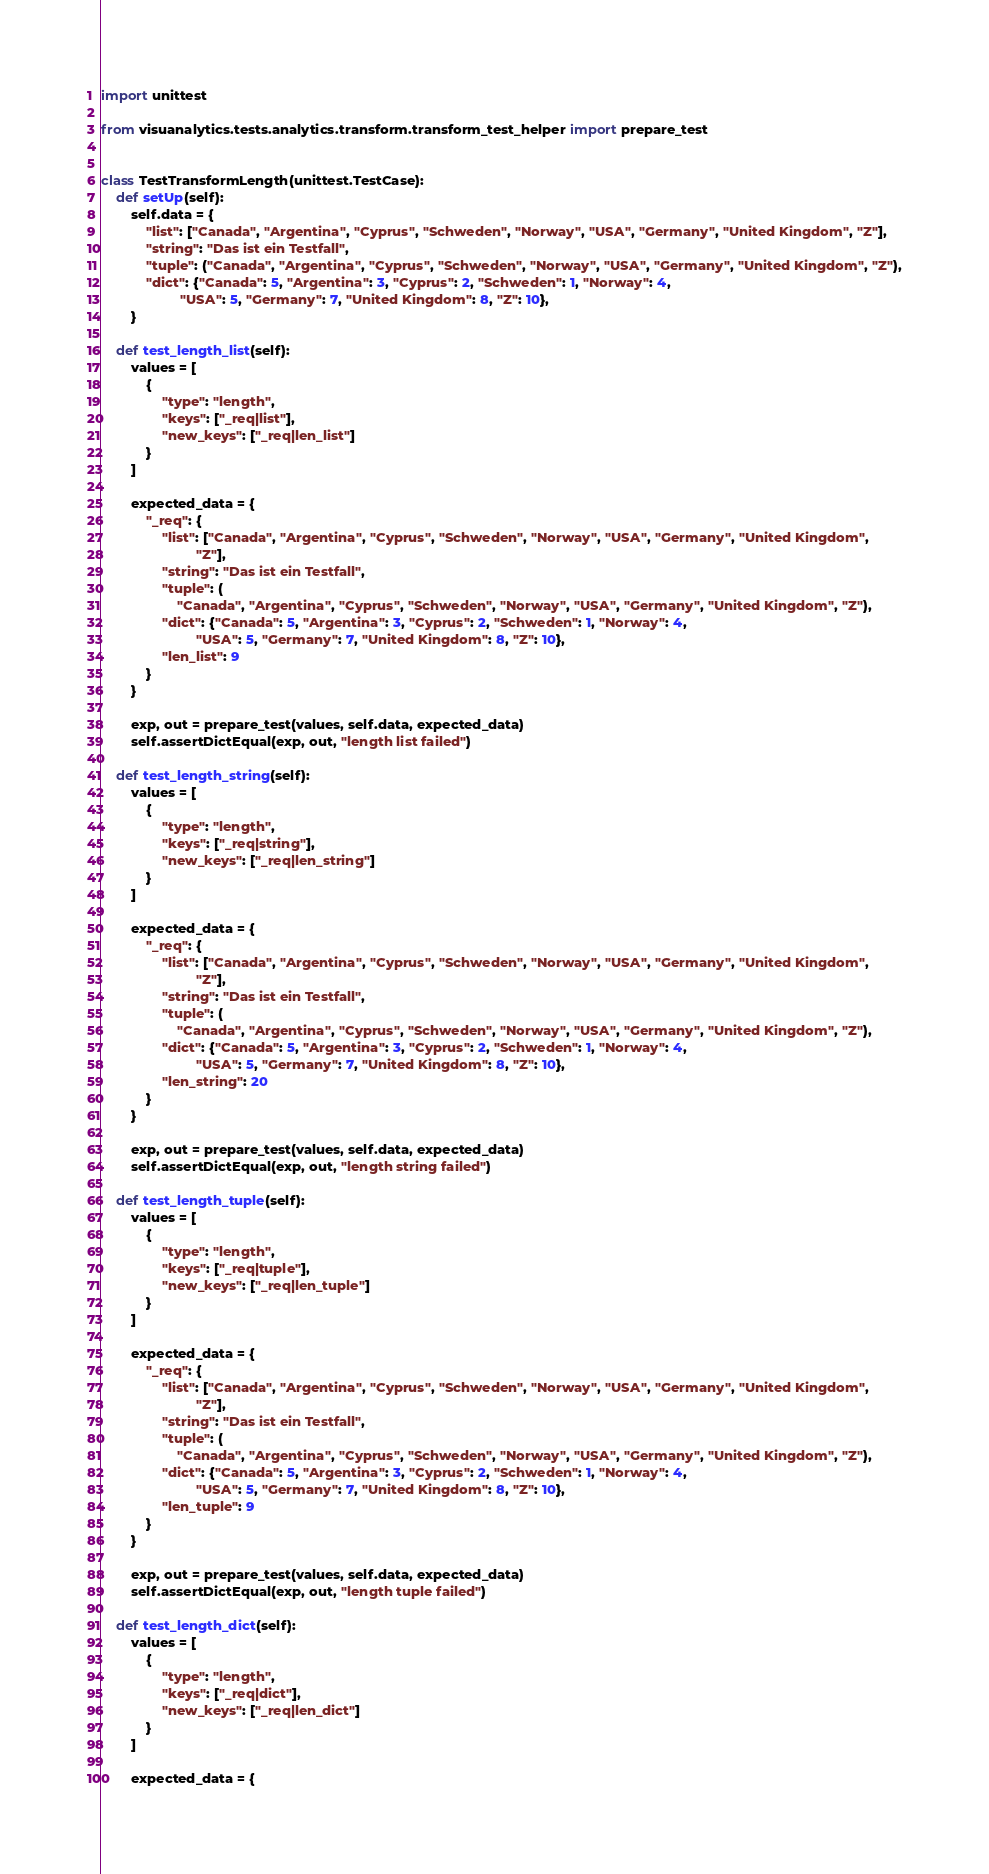Convert code to text. <code><loc_0><loc_0><loc_500><loc_500><_Python_>import unittest

from visuanalytics.tests.analytics.transform.transform_test_helper import prepare_test


class TestTransformLength(unittest.TestCase):
    def setUp(self):
        self.data = {
            "list": ["Canada", "Argentina", "Cyprus", "Schweden", "Norway", "USA", "Germany", "United Kingdom", "Z"],
            "string": "Das ist ein Testfall",
            "tuple": ("Canada", "Argentina", "Cyprus", "Schweden", "Norway", "USA", "Germany", "United Kingdom", "Z"),
            "dict": {"Canada": 5, "Argentina": 3, "Cyprus": 2, "Schweden": 1, "Norway": 4,
                     "USA": 5, "Germany": 7, "United Kingdom": 8, "Z": 10},
        }

    def test_length_list(self):
        values = [
            {
                "type": "length",
                "keys": ["_req|list"],
                "new_keys": ["_req|len_list"]
            }
        ]

        expected_data = {
            "_req": {
                "list": ["Canada", "Argentina", "Cyprus", "Schweden", "Norway", "USA", "Germany", "United Kingdom",
                         "Z"],
                "string": "Das ist ein Testfall",
                "tuple": (
                    "Canada", "Argentina", "Cyprus", "Schweden", "Norway", "USA", "Germany", "United Kingdom", "Z"),
                "dict": {"Canada": 5, "Argentina": 3, "Cyprus": 2, "Schweden": 1, "Norway": 4,
                         "USA": 5, "Germany": 7, "United Kingdom": 8, "Z": 10},
                "len_list": 9
            }
        }

        exp, out = prepare_test(values, self.data, expected_data)
        self.assertDictEqual(exp, out, "length list failed")

    def test_length_string(self):
        values = [
            {
                "type": "length",
                "keys": ["_req|string"],
                "new_keys": ["_req|len_string"]
            }
        ]

        expected_data = {
            "_req": {
                "list": ["Canada", "Argentina", "Cyprus", "Schweden", "Norway", "USA", "Germany", "United Kingdom",
                         "Z"],
                "string": "Das ist ein Testfall",
                "tuple": (
                    "Canada", "Argentina", "Cyprus", "Schweden", "Norway", "USA", "Germany", "United Kingdom", "Z"),
                "dict": {"Canada": 5, "Argentina": 3, "Cyprus": 2, "Schweden": 1, "Norway": 4,
                         "USA": 5, "Germany": 7, "United Kingdom": 8, "Z": 10},
                "len_string": 20
            }
        }

        exp, out = prepare_test(values, self.data, expected_data)
        self.assertDictEqual(exp, out, "length string failed")

    def test_length_tuple(self):
        values = [
            {
                "type": "length",
                "keys": ["_req|tuple"],
                "new_keys": ["_req|len_tuple"]
            }
        ]

        expected_data = {
            "_req": {
                "list": ["Canada", "Argentina", "Cyprus", "Schweden", "Norway", "USA", "Germany", "United Kingdom",
                         "Z"],
                "string": "Das ist ein Testfall",
                "tuple": (
                    "Canada", "Argentina", "Cyprus", "Schweden", "Norway", "USA", "Germany", "United Kingdom", "Z"),
                "dict": {"Canada": 5, "Argentina": 3, "Cyprus": 2, "Schweden": 1, "Norway": 4,
                         "USA": 5, "Germany": 7, "United Kingdom": 8, "Z": 10},
                "len_tuple": 9
            }
        }

        exp, out = prepare_test(values, self.data, expected_data)
        self.assertDictEqual(exp, out, "length tuple failed")

    def test_length_dict(self):
        values = [
            {
                "type": "length",
                "keys": ["_req|dict"],
                "new_keys": ["_req|len_dict"]
            }
        ]

        expected_data = {</code> 